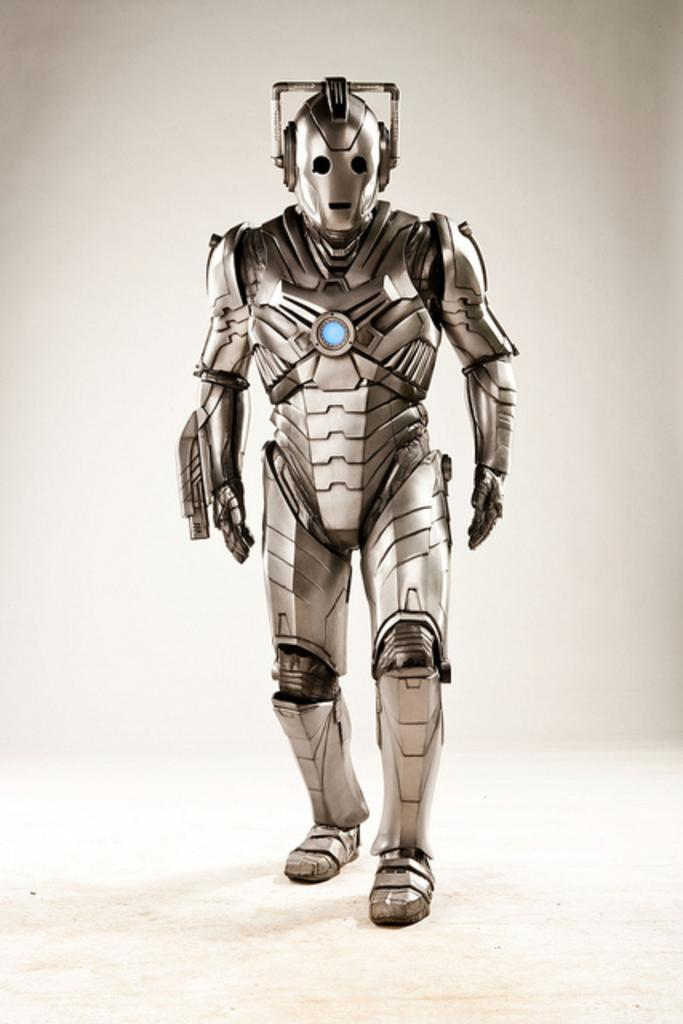What is the main subject of the image? There is a robot in the image. What is the robot doing in the image? The robot is walking. What color is the background of the image? The background of the image is white. How many clovers can be seen growing in the image? There are no clovers present in the image; it features a robot walking against a white background. 